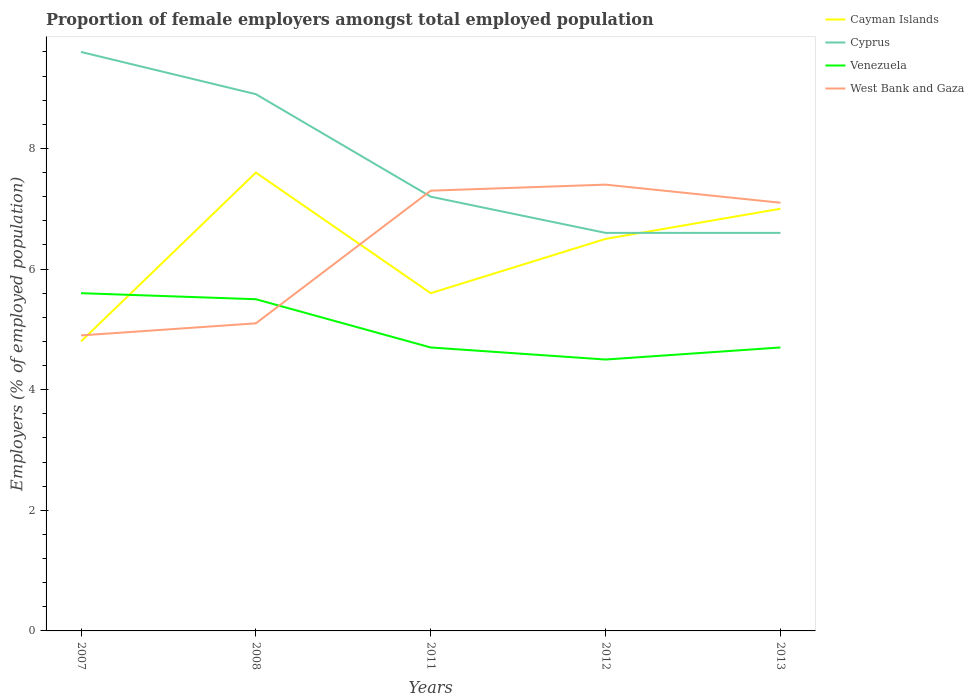How many different coloured lines are there?
Your answer should be compact. 4. Does the line corresponding to Cayman Islands intersect with the line corresponding to Venezuela?
Make the answer very short. Yes. Is the number of lines equal to the number of legend labels?
Your answer should be compact. Yes. Across all years, what is the maximum proportion of female employers in Cayman Islands?
Your answer should be compact. 4.8. In which year was the proportion of female employers in Cayman Islands maximum?
Offer a terse response. 2007. What is the total proportion of female employers in Venezuela in the graph?
Offer a terse response. 0.1. What is the difference between the highest and the second highest proportion of female employers in Cyprus?
Give a very brief answer. 3. Is the proportion of female employers in Cayman Islands strictly greater than the proportion of female employers in Venezuela over the years?
Provide a succinct answer. No. How many years are there in the graph?
Give a very brief answer. 5. What is the difference between two consecutive major ticks on the Y-axis?
Offer a very short reply. 2. Are the values on the major ticks of Y-axis written in scientific E-notation?
Offer a very short reply. No. Does the graph contain any zero values?
Make the answer very short. No. Where does the legend appear in the graph?
Your answer should be very brief. Top right. How many legend labels are there?
Provide a succinct answer. 4. What is the title of the graph?
Provide a succinct answer. Proportion of female employers amongst total employed population. Does "Philippines" appear as one of the legend labels in the graph?
Keep it short and to the point. No. What is the label or title of the Y-axis?
Your answer should be very brief. Employers (% of employed population). What is the Employers (% of employed population) of Cayman Islands in 2007?
Your response must be concise. 4.8. What is the Employers (% of employed population) in Cyprus in 2007?
Offer a very short reply. 9.6. What is the Employers (% of employed population) of Venezuela in 2007?
Your response must be concise. 5.6. What is the Employers (% of employed population) of West Bank and Gaza in 2007?
Provide a succinct answer. 4.9. What is the Employers (% of employed population) in Cayman Islands in 2008?
Your answer should be very brief. 7.6. What is the Employers (% of employed population) in Cyprus in 2008?
Offer a terse response. 8.9. What is the Employers (% of employed population) of Venezuela in 2008?
Give a very brief answer. 5.5. What is the Employers (% of employed population) of West Bank and Gaza in 2008?
Ensure brevity in your answer.  5.1. What is the Employers (% of employed population) in Cayman Islands in 2011?
Give a very brief answer. 5.6. What is the Employers (% of employed population) in Cyprus in 2011?
Make the answer very short. 7.2. What is the Employers (% of employed population) in Venezuela in 2011?
Keep it short and to the point. 4.7. What is the Employers (% of employed population) of West Bank and Gaza in 2011?
Keep it short and to the point. 7.3. What is the Employers (% of employed population) of Cyprus in 2012?
Offer a terse response. 6.6. What is the Employers (% of employed population) of Venezuela in 2012?
Provide a short and direct response. 4.5. What is the Employers (% of employed population) of West Bank and Gaza in 2012?
Keep it short and to the point. 7.4. What is the Employers (% of employed population) in Cayman Islands in 2013?
Offer a terse response. 7. What is the Employers (% of employed population) in Cyprus in 2013?
Your response must be concise. 6.6. What is the Employers (% of employed population) of Venezuela in 2013?
Make the answer very short. 4.7. What is the Employers (% of employed population) of West Bank and Gaza in 2013?
Your response must be concise. 7.1. Across all years, what is the maximum Employers (% of employed population) of Cayman Islands?
Your answer should be very brief. 7.6. Across all years, what is the maximum Employers (% of employed population) in Cyprus?
Give a very brief answer. 9.6. Across all years, what is the maximum Employers (% of employed population) of Venezuela?
Make the answer very short. 5.6. Across all years, what is the maximum Employers (% of employed population) in West Bank and Gaza?
Your response must be concise. 7.4. Across all years, what is the minimum Employers (% of employed population) of Cayman Islands?
Your response must be concise. 4.8. Across all years, what is the minimum Employers (% of employed population) of Cyprus?
Offer a very short reply. 6.6. Across all years, what is the minimum Employers (% of employed population) of West Bank and Gaza?
Your answer should be very brief. 4.9. What is the total Employers (% of employed population) in Cayman Islands in the graph?
Ensure brevity in your answer.  31.5. What is the total Employers (% of employed population) in Cyprus in the graph?
Provide a succinct answer. 38.9. What is the total Employers (% of employed population) in Venezuela in the graph?
Offer a terse response. 25. What is the total Employers (% of employed population) of West Bank and Gaza in the graph?
Provide a succinct answer. 31.8. What is the difference between the Employers (% of employed population) of Cayman Islands in 2007 and that in 2008?
Make the answer very short. -2.8. What is the difference between the Employers (% of employed population) in Cayman Islands in 2007 and that in 2011?
Your answer should be very brief. -0.8. What is the difference between the Employers (% of employed population) of Venezuela in 2007 and that in 2011?
Keep it short and to the point. 0.9. What is the difference between the Employers (% of employed population) of West Bank and Gaza in 2007 and that in 2011?
Your answer should be very brief. -2.4. What is the difference between the Employers (% of employed population) in Cayman Islands in 2007 and that in 2012?
Your response must be concise. -1.7. What is the difference between the Employers (% of employed population) in Cayman Islands in 2007 and that in 2013?
Offer a very short reply. -2.2. What is the difference between the Employers (% of employed population) in Cyprus in 2007 and that in 2013?
Make the answer very short. 3. What is the difference between the Employers (% of employed population) of Venezuela in 2007 and that in 2013?
Offer a very short reply. 0.9. What is the difference between the Employers (% of employed population) in West Bank and Gaza in 2007 and that in 2013?
Keep it short and to the point. -2.2. What is the difference between the Employers (% of employed population) in Venezuela in 2008 and that in 2011?
Provide a short and direct response. 0.8. What is the difference between the Employers (% of employed population) of West Bank and Gaza in 2008 and that in 2011?
Offer a terse response. -2.2. What is the difference between the Employers (% of employed population) in Cyprus in 2008 and that in 2012?
Offer a terse response. 2.3. What is the difference between the Employers (% of employed population) of Cayman Islands in 2008 and that in 2013?
Provide a succinct answer. 0.6. What is the difference between the Employers (% of employed population) in Cyprus in 2008 and that in 2013?
Offer a very short reply. 2.3. What is the difference between the Employers (% of employed population) of Cayman Islands in 2011 and that in 2012?
Your answer should be compact. -0.9. What is the difference between the Employers (% of employed population) in Venezuela in 2011 and that in 2012?
Make the answer very short. 0.2. What is the difference between the Employers (% of employed population) in West Bank and Gaza in 2011 and that in 2012?
Keep it short and to the point. -0.1. What is the difference between the Employers (% of employed population) of Cyprus in 2011 and that in 2013?
Provide a succinct answer. 0.6. What is the difference between the Employers (% of employed population) of Venezuela in 2011 and that in 2013?
Your answer should be compact. 0. What is the difference between the Employers (% of employed population) of Cayman Islands in 2007 and the Employers (% of employed population) of Venezuela in 2008?
Offer a very short reply. -0.7. What is the difference between the Employers (% of employed population) of Cayman Islands in 2007 and the Employers (% of employed population) of West Bank and Gaza in 2008?
Your answer should be compact. -0.3. What is the difference between the Employers (% of employed population) of Cyprus in 2007 and the Employers (% of employed population) of West Bank and Gaza in 2008?
Make the answer very short. 4.5. What is the difference between the Employers (% of employed population) in Venezuela in 2007 and the Employers (% of employed population) in West Bank and Gaza in 2008?
Provide a succinct answer. 0.5. What is the difference between the Employers (% of employed population) of Cayman Islands in 2007 and the Employers (% of employed population) of Cyprus in 2011?
Your response must be concise. -2.4. What is the difference between the Employers (% of employed population) in Cayman Islands in 2007 and the Employers (% of employed population) in West Bank and Gaza in 2011?
Make the answer very short. -2.5. What is the difference between the Employers (% of employed population) of Cyprus in 2007 and the Employers (% of employed population) of West Bank and Gaza in 2011?
Provide a short and direct response. 2.3. What is the difference between the Employers (% of employed population) of Venezuela in 2007 and the Employers (% of employed population) of West Bank and Gaza in 2011?
Ensure brevity in your answer.  -1.7. What is the difference between the Employers (% of employed population) of Cayman Islands in 2007 and the Employers (% of employed population) of Cyprus in 2012?
Make the answer very short. -1.8. What is the difference between the Employers (% of employed population) in Cayman Islands in 2007 and the Employers (% of employed population) in Venezuela in 2012?
Offer a very short reply. 0.3. What is the difference between the Employers (% of employed population) in Cayman Islands in 2007 and the Employers (% of employed population) in West Bank and Gaza in 2012?
Keep it short and to the point. -2.6. What is the difference between the Employers (% of employed population) in Venezuela in 2007 and the Employers (% of employed population) in West Bank and Gaza in 2012?
Your answer should be very brief. -1.8. What is the difference between the Employers (% of employed population) of Cayman Islands in 2007 and the Employers (% of employed population) of Cyprus in 2013?
Your answer should be very brief. -1.8. What is the difference between the Employers (% of employed population) in Cayman Islands in 2007 and the Employers (% of employed population) in Venezuela in 2013?
Offer a terse response. 0.1. What is the difference between the Employers (% of employed population) of Cayman Islands in 2007 and the Employers (% of employed population) of West Bank and Gaza in 2013?
Provide a succinct answer. -2.3. What is the difference between the Employers (% of employed population) of Cyprus in 2007 and the Employers (% of employed population) of West Bank and Gaza in 2013?
Keep it short and to the point. 2.5. What is the difference between the Employers (% of employed population) of Cayman Islands in 2008 and the Employers (% of employed population) of Cyprus in 2011?
Ensure brevity in your answer.  0.4. What is the difference between the Employers (% of employed population) of Cayman Islands in 2008 and the Employers (% of employed population) of West Bank and Gaza in 2011?
Provide a succinct answer. 0.3. What is the difference between the Employers (% of employed population) in Cayman Islands in 2008 and the Employers (% of employed population) in Cyprus in 2012?
Offer a very short reply. 1. What is the difference between the Employers (% of employed population) in Cayman Islands in 2008 and the Employers (% of employed population) in Venezuela in 2012?
Offer a very short reply. 3.1. What is the difference between the Employers (% of employed population) in Cayman Islands in 2008 and the Employers (% of employed population) in West Bank and Gaza in 2012?
Offer a very short reply. 0.2. What is the difference between the Employers (% of employed population) in Cyprus in 2008 and the Employers (% of employed population) in Venezuela in 2012?
Provide a succinct answer. 4.4. What is the difference between the Employers (% of employed population) in Cayman Islands in 2008 and the Employers (% of employed population) in Venezuela in 2013?
Give a very brief answer. 2.9. What is the difference between the Employers (% of employed population) in Cayman Islands in 2008 and the Employers (% of employed population) in West Bank and Gaza in 2013?
Provide a succinct answer. 0.5. What is the difference between the Employers (% of employed population) of Cyprus in 2008 and the Employers (% of employed population) of Venezuela in 2013?
Your answer should be compact. 4.2. What is the difference between the Employers (% of employed population) of Cyprus in 2008 and the Employers (% of employed population) of West Bank and Gaza in 2013?
Keep it short and to the point. 1.8. What is the difference between the Employers (% of employed population) in Venezuela in 2008 and the Employers (% of employed population) in West Bank and Gaza in 2013?
Offer a very short reply. -1.6. What is the difference between the Employers (% of employed population) in Cayman Islands in 2011 and the Employers (% of employed population) in Venezuela in 2012?
Your response must be concise. 1.1. What is the difference between the Employers (% of employed population) in Cayman Islands in 2011 and the Employers (% of employed population) in West Bank and Gaza in 2012?
Offer a very short reply. -1.8. What is the difference between the Employers (% of employed population) in Cyprus in 2011 and the Employers (% of employed population) in Venezuela in 2012?
Offer a very short reply. 2.7. What is the difference between the Employers (% of employed population) of Cyprus in 2011 and the Employers (% of employed population) of West Bank and Gaza in 2012?
Your response must be concise. -0.2. What is the difference between the Employers (% of employed population) in Cayman Islands in 2011 and the Employers (% of employed population) in Cyprus in 2013?
Provide a short and direct response. -1. What is the difference between the Employers (% of employed population) of Cayman Islands in 2011 and the Employers (% of employed population) of Venezuela in 2013?
Make the answer very short. 0.9. What is the difference between the Employers (% of employed population) of Cayman Islands in 2011 and the Employers (% of employed population) of West Bank and Gaza in 2013?
Your response must be concise. -1.5. What is the difference between the Employers (% of employed population) in Cyprus in 2011 and the Employers (% of employed population) in Venezuela in 2013?
Your answer should be very brief. 2.5. What is the difference between the Employers (% of employed population) in Cyprus in 2011 and the Employers (% of employed population) in West Bank and Gaza in 2013?
Keep it short and to the point. 0.1. What is the difference between the Employers (% of employed population) of Cayman Islands in 2012 and the Employers (% of employed population) of West Bank and Gaza in 2013?
Offer a terse response. -0.6. What is the difference between the Employers (% of employed population) of Cyprus in 2012 and the Employers (% of employed population) of Venezuela in 2013?
Ensure brevity in your answer.  1.9. What is the difference between the Employers (% of employed population) in Cyprus in 2012 and the Employers (% of employed population) in West Bank and Gaza in 2013?
Give a very brief answer. -0.5. What is the difference between the Employers (% of employed population) of Venezuela in 2012 and the Employers (% of employed population) of West Bank and Gaza in 2013?
Your answer should be compact. -2.6. What is the average Employers (% of employed population) of Cyprus per year?
Give a very brief answer. 7.78. What is the average Employers (% of employed population) of Venezuela per year?
Offer a very short reply. 5. What is the average Employers (% of employed population) in West Bank and Gaza per year?
Your response must be concise. 6.36. In the year 2007, what is the difference between the Employers (% of employed population) in Cayman Islands and Employers (% of employed population) in Cyprus?
Ensure brevity in your answer.  -4.8. In the year 2007, what is the difference between the Employers (% of employed population) in Cayman Islands and Employers (% of employed population) in Venezuela?
Your answer should be very brief. -0.8. In the year 2007, what is the difference between the Employers (% of employed population) in Cayman Islands and Employers (% of employed population) in West Bank and Gaza?
Provide a succinct answer. -0.1. In the year 2007, what is the difference between the Employers (% of employed population) in Cyprus and Employers (% of employed population) in West Bank and Gaza?
Ensure brevity in your answer.  4.7. In the year 2007, what is the difference between the Employers (% of employed population) in Venezuela and Employers (% of employed population) in West Bank and Gaza?
Provide a short and direct response. 0.7. In the year 2008, what is the difference between the Employers (% of employed population) in Cayman Islands and Employers (% of employed population) in West Bank and Gaza?
Give a very brief answer. 2.5. In the year 2011, what is the difference between the Employers (% of employed population) of Cayman Islands and Employers (% of employed population) of Cyprus?
Keep it short and to the point. -1.6. In the year 2011, what is the difference between the Employers (% of employed population) in Cayman Islands and Employers (% of employed population) in Venezuela?
Keep it short and to the point. 0.9. In the year 2011, what is the difference between the Employers (% of employed population) in Cayman Islands and Employers (% of employed population) in West Bank and Gaza?
Keep it short and to the point. -1.7. In the year 2011, what is the difference between the Employers (% of employed population) in Cyprus and Employers (% of employed population) in Venezuela?
Ensure brevity in your answer.  2.5. In the year 2012, what is the difference between the Employers (% of employed population) in Cayman Islands and Employers (% of employed population) in Cyprus?
Your answer should be compact. -0.1. In the year 2012, what is the difference between the Employers (% of employed population) of Cayman Islands and Employers (% of employed population) of Venezuela?
Your answer should be compact. 2. In the year 2012, what is the difference between the Employers (% of employed population) of Cayman Islands and Employers (% of employed population) of West Bank and Gaza?
Provide a short and direct response. -0.9. In the year 2012, what is the difference between the Employers (% of employed population) in Cyprus and Employers (% of employed population) in West Bank and Gaza?
Offer a very short reply. -0.8. In the year 2013, what is the difference between the Employers (% of employed population) in Cayman Islands and Employers (% of employed population) in Venezuela?
Make the answer very short. 2.3. In the year 2013, what is the difference between the Employers (% of employed population) of Cyprus and Employers (% of employed population) of West Bank and Gaza?
Ensure brevity in your answer.  -0.5. In the year 2013, what is the difference between the Employers (% of employed population) in Venezuela and Employers (% of employed population) in West Bank and Gaza?
Your answer should be very brief. -2.4. What is the ratio of the Employers (% of employed population) of Cayman Islands in 2007 to that in 2008?
Your answer should be compact. 0.63. What is the ratio of the Employers (% of employed population) in Cyprus in 2007 to that in 2008?
Provide a short and direct response. 1.08. What is the ratio of the Employers (% of employed population) in Venezuela in 2007 to that in 2008?
Make the answer very short. 1.02. What is the ratio of the Employers (% of employed population) in West Bank and Gaza in 2007 to that in 2008?
Make the answer very short. 0.96. What is the ratio of the Employers (% of employed population) in Cayman Islands in 2007 to that in 2011?
Your answer should be very brief. 0.86. What is the ratio of the Employers (% of employed population) of Venezuela in 2007 to that in 2011?
Give a very brief answer. 1.19. What is the ratio of the Employers (% of employed population) of West Bank and Gaza in 2007 to that in 2011?
Your answer should be very brief. 0.67. What is the ratio of the Employers (% of employed population) in Cayman Islands in 2007 to that in 2012?
Offer a terse response. 0.74. What is the ratio of the Employers (% of employed population) in Cyprus in 2007 to that in 2012?
Your answer should be very brief. 1.45. What is the ratio of the Employers (% of employed population) in Venezuela in 2007 to that in 2012?
Your response must be concise. 1.24. What is the ratio of the Employers (% of employed population) in West Bank and Gaza in 2007 to that in 2012?
Offer a terse response. 0.66. What is the ratio of the Employers (% of employed population) in Cayman Islands in 2007 to that in 2013?
Ensure brevity in your answer.  0.69. What is the ratio of the Employers (% of employed population) of Cyprus in 2007 to that in 2013?
Make the answer very short. 1.45. What is the ratio of the Employers (% of employed population) of Venezuela in 2007 to that in 2013?
Offer a terse response. 1.19. What is the ratio of the Employers (% of employed population) of West Bank and Gaza in 2007 to that in 2013?
Your answer should be compact. 0.69. What is the ratio of the Employers (% of employed population) in Cayman Islands in 2008 to that in 2011?
Give a very brief answer. 1.36. What is the ratio of the Employers (% of employed population) of Cyprus in 2008 to that in 2011?
Your answer should be compact. 1.24. What is the ratio of the Employers (% of employed population) in Venezuela in 2008 to that in 2011?
Offer a terse response. 1.17. What is the ratio of the Employers (% of employed population) in West Bank and Gaza in 2008 to that in 2011?
Provide a short and direct response. 0.7. What is the ratio of the Employers (% of employed population) of Cayman Islands in 2008 to that in 2012?
Provide a short and direct response. 1.17. What is the ratio of the Employers (% of employed population) in Cyprus in 2008 to that in 2012?
Your answer should be very brief. 1.35. What is the ratio of the Employers (% of employed population) in Venezuela in 2008 to that in 2012?
Offer a very short reply. 1.22. What is the ratio of the Employers (% of employed population) of West Bank and Gaza in 2008 to that in 2012?
Give a very brief answer. 0.69. What is the ratio of the Employers (% of employed population) in Cayman Islands in 2008 to that in 2013?
Your answer should be very brief. 1.09. What is the ratio of the Employers (% of employed population) in Cyprus in 2008 to that in 2013?
Provide a short and direct response. 1.35. What is the ratio of the Employers (% of employed population) of Venezuela in 2008 to that in 2013?
Your response must be concise. 1.17. What is the ratio of the Employers (% of employed population) of West Bank and Gaza in 2008 to that in 2013?
Your answer should be compact. 0.72. What is the ratio of the Employers (% of employed population) in Cayman Islands in 2011 to that in 2012?
Ensure brevity in your answer.  0.86. What is the ratio of the Employers (% of employed population) in Cyprus in 2011 to that in 2012?
Give a very brief answer. 1.09. What is the ratio of the Employers (% of employed population) in Venezuela in 2011 to that in 2012?
Your response must be concise. 1.04. What is the ratio of the Employers (% of employed population) in West Bank and Gaza in 2011 to that in 2012?
Your answer should be very brief. 0.99. What is the ratio of the Employers (% of employed population) of Cyprus in 2011 to that in 2013?
Give a very brief answer. 1.09. What is the ratio of the Employers (% of employed population) in Venezuela in 2011 to that in 2013?
Ensure brevity in your answer.  1. What is the ratio of the Employers (% of employed population) in West Bank and Gaza in 2011 to that in 2013?
Your answer should be compact. 1.03. What is the ratio of the Employers (% of employed population) in Cayman Islands in 2012 to that in 2013?
Give a very brief answer. 0.93. What is the ratio of the Employers (% of employed population) in Cyprus in 2012 to that in 2013?
Offer a terse response. 1. What is the ratio of the Employers (% of employed population) in Venezuela in 2012 to that in 2013?
Make the answer very short. 0.96. What is the ratio of the Employers (% of employed population) of West Bank and Gaza in 2012 to that in 2013?
Your response must be concise. 1.04. What is the difference between the highest and the second highest Employers (% of employed population) in Cayman Islands?
Your answer should be compact. 0.6. What is the difference between the highest and the lowest Employers (% of employed population) in Venezuela?
Provide a short and direct response. 1.1. What is the difference between the highest and the lowest Employers (% of employed population) in West Bank and Gaza?
Provide a succinct answer. 2.5. 